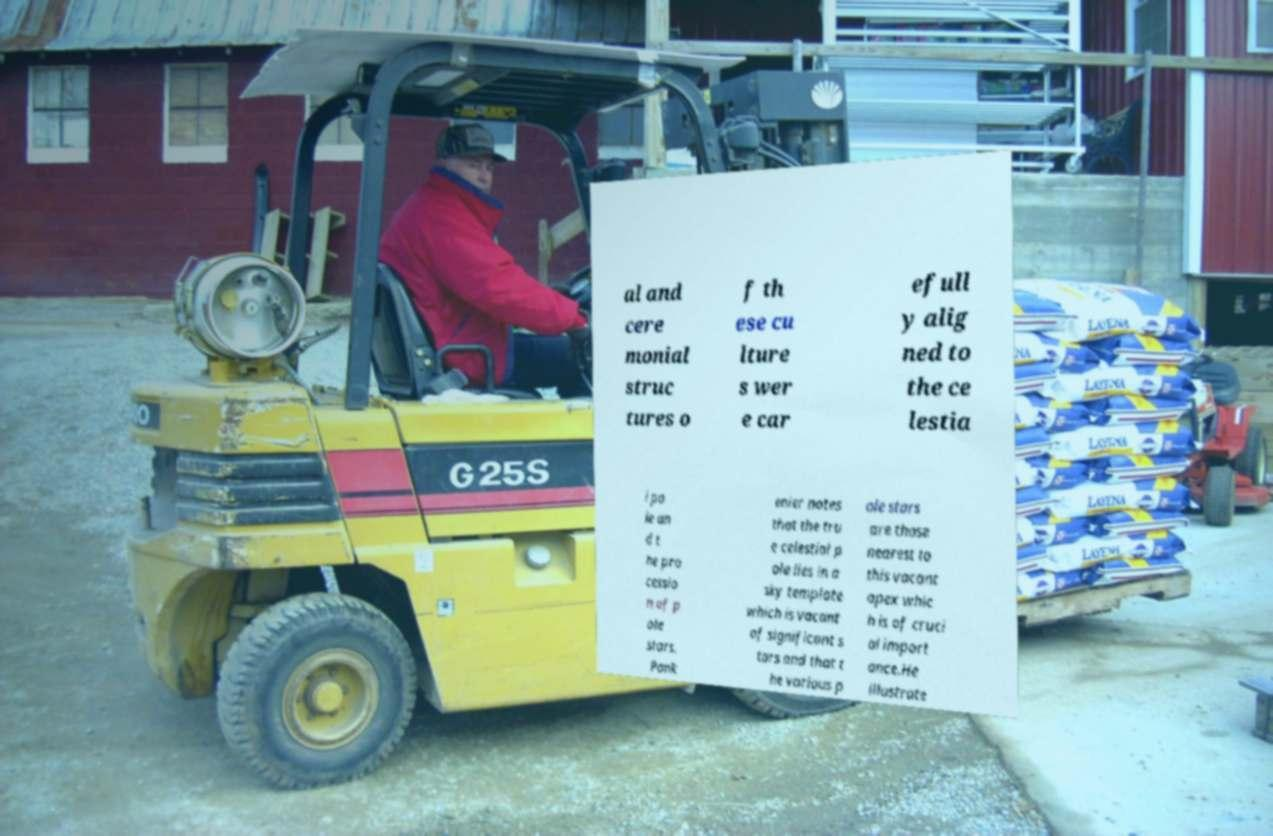Please identify and transcribe the text found in this image. al and cere monial struc tures o f th ese cu lture s wer e car efull y alig ned to the ce lestia l po le an d t he pro cessio n of p ole stars. Pank enier notes that the tru e celestial p ole lies in a sky template which is vacant of significant s tars and that t he various p ole stars are those nearest to this vacant apex whic h is of cruci al import ance.He illustrate 